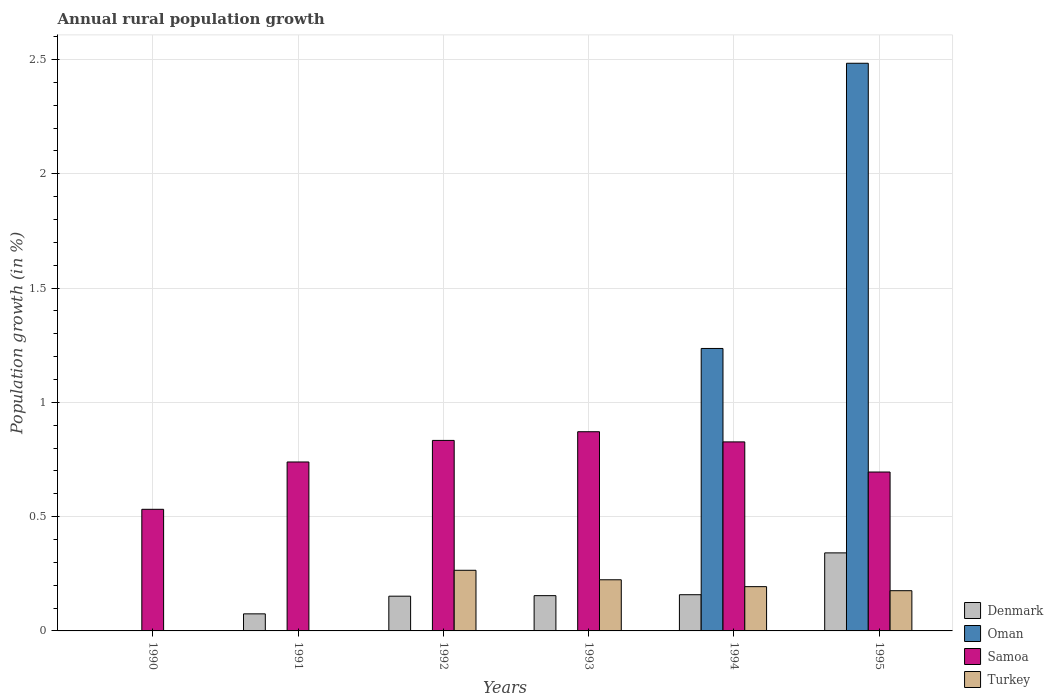How many different coloured bars are there?
Make the answer very short. 4. What is the percentage of rural population growth in Oman in 1992?
Offer a very short reply. 0. Across all years, what is the maximum percentage of rural population growth in Samoa?
Make the answer very short. 0.87. What is the total percentage of rural population growth in Oman in the graph?
Make the answer very short. 3.72. What is the difference between the percentage of rural population growth in Denmark in 1994 and that in 1995?
Give a very brief answer. -0.18. What is the difference between the percentage of rural population growth in Samoa in 1994 and the percentage of rural population growth in Oman in 1995?
Offer a very short reply. -1.66. What is the average percentage of rural population growth in Turkey per year?
Provide a short and direct response. 0.14. In the year 1995, what is the difference between the percentage of rural population growth in Denmark and percentage of rural population growth in Oman?
Your response must be concise. -2.14. What is the ratio of the percentage of rural population growth in Denmark in 1992 to that in 1993?
Your answer should be very brief. 0.98. Is the percentage of rural population growth in Samoa in 1993 less than that in 1995?
Your answer should be very brief. No. What is the difference between the highest and the second highest percentage of rural population growth in Denmark?
Your response must be concise. 0.18. What is the difference between the highest and the lowest percentage of rural population growth in Denmark?
Give a very brief answer. 0.34. Is the sum of the percentage of rural population growth in Turkey in 1992 and 1994 greater than the maximum percentage of rural population growth in Denmark across all years?
Provide a succinct answer. Yes. Is it the case that in every year, the sum of the percentage of rural population growth in Turkey and percentage of rural population growth in Oman is greater than the sum of percentage of rural population growth in Samoa and percentage of rural population growth in Denmark?
Your answer should be compact. No. Are all the bars in the graph horizontal?
Keep it short and to the point. No. Are the values on the major ticks of Y-axis written in scientific E-notation?
Offer a terse response. No. Does the graph contain any zero values?
Offer a terse response. Yes. Where does the legend appear in the graph?
Provide a succinct answer. Bottom right. How many legend labels are there?
Keep it short and to the point. 4. What is the title of the graph?
Ensure brevity in your answer.  Annual rural population growth. Does "Kenya" appear as one of the legend labels in the graph?
Offer a terse response. No. What is the label or title of the Y-axis?
Provide a short and direct response. Population growth (in %). What is the Population growth (in %) of Denmark in 1990?
Make the answer very short. 0. What is the Population growth (in %) of Samoa in 1990?
Make the answer very short. 0.53. What is the Population growth (in %) in Denmark in 1991?
Provide a short and direct response. 0.07. What is the Population growth (in %) of Samoa in 1991?
Offer a very short reply. 0.74. What is the Population growth (in %) of Denmark in 1992?
Provide a short and direct response. 0.15. What is the Population growth (in %) in Samoa in 1992?
Your answer should be very brief. 0.83. What is the Population growth (in %) of Turkey in 1992?
Provide a succinct answer. 0.27. What is the Population growth (in %) in Denmark in 1993?
Offer a terse response. 0.15. What is the Population growth (in %) of Oman in 1993?
Your response must be concise. 0. What is the Population growth (in %) in Samoa in 1993?
Your answer should be very brief. 0.87. What is the Population growth (in %) of Turkey in 1993?
Your answer should be compact. 0.22. What is the Population growth (in %) in Denmark in 1994?
Ensure brevity in your answer.  0.16. What is the Population growth (in %) in Oman in 1994?
Offer a terse response. 1.24. What is the Population growth (in %) of Samoa in 1994?
Provide a short and direct response. 0.83. What is the Population growth (in %) of Turkey in 1994?
Your response must be concise. 0.19. What is the Population growth (in %) of Denmark in 1995?
Provide a short and direct response. 0.34. What is the Population growth (in %) in Oman in 1995?
Your response must be concise. 2.48. What is the Population growth (in %) in Samoa in 1995?
Keep it short and to the point. 0.7. What is the Population growth (in %) in Turkey in 1995?
Keep it short and to the point. 0.18. Across all years, what is the maximum Population growth (in %) of Denmark?
Provide a succinct answer. 0.34. Across all years, what is the maximum Population growth (in %) of Oman?
Make the answer very short. 2.48. Across all years, what is the maximum Population growth (in %) in Samoa?
Your answer should be very brief. 0.87. Across all years, what is the maximum Population growth (in %) of Turkey?
Your response must be concise. 0.27. Across all years, what is the minimum Population growth (in %) in Denmark?
Make the answer very short. 0. Across all years, what is the minimum Population growth (in %) of Samoa?
Make the answer very short. 0.53. Across all years, what is the minimum Population growth (in %) in Turkey?
Provide a succinct answer. 0. What is the total Population growth (in %) in Denmark in the graph?
Make the answer very short. 0.88. What is the total Population growth (in %) in Oman in the graph?
Offer a terse response. 3.72. What is the total Population growth (in %) of Samoa in the graph?
Give a very brief answer. 4.5. What is the total Population growth (in %) of Turkey in the graph?
Give a very brief answer. 0.86. What is the difference between the Population growth (in %) in Samoa in 1990 and that in 1991?
Provide a short and direct response. -0.21. What is the difference between the Population growth (in %) of Samoa in 1990 and that in 1992?
Give a very brief answer. -0.3. What is the difference between the Population growth (in %) of Samoa in 1990 and that in 1993?
Provide a short and direct response. -0.34. What is the difference between the Population growth (in %) of Samoa in 1990 and that in 1994?
Give a very brief answer. -0.29. What is the difference between the Population growth (in %) of Samoa in 1990 and that in 1995?
Give a very brief answer. -0.16. What is the difference between the Population growth (in %) in Denmark in 1991 and that in 1992?
Provide a short and direct response. -0.08. What is the difference between the Population growth (in %) in Samoa in 1991 and that in 1992?
Provide a succinct answer. -0.09. What is the difference between the Population growth (in %) of Denmark in 1991 and that in 1993?
Your answer should be very brief. -0.08. What is the difference between the Population growth (in %) of Samoa in 1991 and that in 1993?
Your response must be concise. -0.13. What is the difference between the Population growth (in %) of Denmark in 1991 and that in 1994?
Give a very brief answer. -0.08. What is the difference between the Population growth (in %) in Samoa in 1991 and that in 1994?
Ensure brevity in your answer.  -0.09. What is the difference between the Population growth (in %) in Denmark in 1991 and that in 1995?
Your response must be concise. -0.27. What is the difference between the Population growth (in %) of Samoa in 1991 and that in 1995?
Your answer should be very brief. 0.04. What is the difference between the Population growth (in %) in Denmark in 1992 and that in 1993?
Your answer should be very brief. -0. What is the difference between the Population growth (in %) in Samoa in 1992 and that in 1993?
Keep it short and to the point. -0.04. What is the difference between the Population growth (in %) of Turkey in 1992 and that in 1993?
Provide a succinct answer. 0.04. What is the difference between the Population growth (in %) of Denmark in 1992 and that in 1994?
Provide a succinct answer. -0.01. What is the difference between the Population growth (in %) in Samoa in 1992 and that in 1994?
Offer a very short reply. 0.01. What is the difference between the Population growth (in %) of Turkey in 1992 and that in 1994?
Your response must be concise. 0.07. What is the difference between the Population growth (in %) in Denmark in 1992 and that in 1995?
Your answer should be compact. -0.19. What is the difference between the Population growth (in %) in Samoa in 1992 and that in 1995?
Offer a terse response. 0.14. What is the difference between the Population growth (in %) in Turkey in 1992 and that in 1995?
Keep it short and to the point. 0.09. What is the difference between the Population growth (in %) in Denmark in 1993 and that in 1994?
Provide a succinct answer. -0. What is the difference between the Population growth (in %) of Samoa in 1993 and that in 1994?
Your answer should be very brief. 0.04. What is the difference between the Population growth (in %) of Turkey in 1993 and that in 1994?
Provide a short and direct response. 0.03. What is the difference between the Population growth (in %) in Denmark in 1993 and that in 1995?
Provide a succinct answer. -0.19. What is the difference between the Population growth (in %) in Samoa in 1993 and that in 1995?
Provide a succinct answer. 0.18. What is the difference between the Population growth (in %) of Turkey in 1993 and that in 1995?
Give a very brief answer. 0.05. What is the difference between the Population growth (in %) in Denmark in 1994 and that in 1995?
Offer a terse response. -0.18. What is the difference between the Population growth (in %) in Oman in 1994 and that in 1995?
Make the answer very short. -1.25. What is the difference between the Population growth (in %) of Samoa in 1994 and that in 1995?
Keep it short and to the point. 0.13. What is the difference between the Population growth (in %) of Turkey in 1994 and that in 1995?
Offer a very short reply. 0.02. What is the difference between the Population growth (in %) of Samoa in 1990 and the Population growth (in %) of Turkey in 1992?
Offer a very short reply. 0.27. What is the difference between the Population growth (in %) of Samoa in 1990 and the Population growth (in %) of Turkey in 1993?
Offer a terse response. 0.31. What is the difference between the Population growth (in %) in Samoa in 1990 and the Population growth (in %) in Turkey in 1994?
Keep it short and to the point. 0.34. What is the difference between the Population growth (in %) in Samoa in 1990 and the Population growth (in %) in Turkey in 1995?
Provide a short and direct response. 0.36. What is the difference between the Population growth (in %) of Denmark in 1991 and the Population growth (in %) of Samoa in 1992?
Offer a terse response. -0.76. What is the difference between the Population growth (in %) in Denmark in 1991 and the Population growth (in %) in Turkey in 1992?
Your response must be concise. -0.19. What is the difference between the Population growth (in %) in Samoa in 1991 and the Population growth (in %) in Turkey in 1992?
Offer a very short reply. 0.47. What is the difference between the Population growth (in %) in Denmark in 1991 and the Population growth (in %) in Samoa in 1993?
Make the answer very short. -0.8. What is the difference between the Population growth (in %) in Denmark in 1991 and the Population growth (in %) in Turkey in 1993?
Your answer should be very brief. -0.15. What is the difference between the Population growth (in %) in Samoa in 1991 and the Population growth (in %) in Turkey in 1993?
Provide a short and direct response. 0.52. What is the difference between the Population growth (in %) of Denmark in 1991 and the Population growth (in %) of Oman in 1994?
Your response must be concise. -1.16. What is the difference between the Population growth (in %) in Denmark in 1991 and the Population growth (in %) in Samoa in 1994?
Ensure brevity in your answer.  -0.75. What is the difference between the Population growth (in %) in Denmark in 1991 and the Population growth (in %) in Turkey in 1994?
Your response must be concise. -0.12. What is the difference between the Population growth (in %) in Samoa in 1991 and the Population growth (in %) in Turkey in 1994?
Provide a succinct answer. 0.55. What is the difference between the Population growth (in %) in Denmark in 1991 and the Population growth (in %) in Oman in 1995?
Offer a terse response. -2.41. What is the difference between the Population growth (in %) in Denmark in 1991 and the Population growth (in %) in Samoa in 1995?
Ensure brevity in your answer.  -0.62. What is the difference between the Population growth (in %) of Denmark in 1991 and the Population growth (in %) of Turkey in 1995?
Make the answer very short. -0.1. What is the difference between the Population growth (in %) in Samoa in 1991 and the Population growth (in %) in Turkey in 1995?
Your answer should be very brief. 0.56. What is the difference between the Population growth (in %) in Denmark in 1992 and the Population growth (in %) in Samoa in 1993?
Provide a succinct answer. -0.72. What is the difference between the Population growth (in %) in Denmark in 1992 and the Population growth (in %) in Turkey in 1993?
Keep it short and to the point. -0.07. What is the difference between the Population growth (in %) of Samoa in 1992 and the Population growth (in %) of Turkey in 1993?
Provide a short and direct response. 0.61. What is the difference between the Population growth (in %) of Denmark in 1992 and the Population growth (in %) of Oman in 1994?
Your answer should be very brief. -1.08. What is the difference between the Population growth (in %) in Denmark in 1992 and the Population growth (in %) in Samoa in 1994?
Offer a terse response. -0.67. What is the difference between the Population growth (in %) of Denmark in 1992 and the Population growth (in %) of Turkey in 1994?
Your response must be concise. -0.04. What is the difference between the Population growth (in %) in Samoa in 1992 and the Population growth (in %) in Turkey in 1994?
Your answer should be very brief. 0.64. What is the difference between the Population growth (in %) of Denmark in 1992 and the Population growth (in %) of Oman in 1995?
Keep it short and to the point. -2.33. What is the difference between the Population growth (in %) of Denmark in 1992 and the Population growth (in %) of Samoa in 1995?
Your answer should be very brief. -0.54. What is the difference between the Population growth (in %) of Denmark in 1992 and the Population growth (in %) of Turkey in 1995?
Keep it short and to the point. -0.02. What is the difference between the Population growth (in %) of Samoa in 1992 and the Population growth (in %) of Turkey in 1995?
Keep it short and to the point. 0.66. What is the difference between the Population growth (in %) of Denmark in 1993 and the Population growth (in %) of Oman in 1994?
Give a very brief answer. -1.08. What is the difference between the Population growth (in %) in Denmark in 1993 and the Population growth (in %) in Samoa in 1994?
Provide a short and direct response. -0.67. What is the difference between the Population growth (in %) in Denmark in 1993 and the Population growth (in %) in Turkey in 1994?
Provide a short and direct response. -0.04. What is the difference between the Population growth (in %) in Samoa in 1993 and the Population growth (in %) in Turkey in 1994?
Provide a short and direct response. 0.68. What is the difference between the Population growth (in %) in Denmark in 1993 and the Population growth (in %) in Oman in 1995?
Your answer should be very brief. -2.33. What is the difference between the Population growth (in %) in Denmark in 1993 and the Population growth (in %) in Samoa in 1995?
Offer a very short reply. -0.54. What is the difference between the Population growth (in %) in Denmark in 1993 and the Population growth (in %) in Turkey in 1995?
Your answer should be compact. -0.02. What is the difference between the Population growth (in %) of Samoa in 1993 and the Population growth (in %) of Turkey in 1995?
Your answer should be very brief. 0.7. What is the difference between the Population growth (in %) of Denmark in 1994 and the Population growth (in %) of Oman in 1995?
Ensure brevity in your answer.  -2.32. What is the difference between the Population growth (in %) in Denmark in 1994 and the Population growth (in %) in Samoa in 1995?
Your response must be concise. -0.54. What is the difference between the Population growth (in %) in Denmark in 1994 and the Population growth (in %) in Turkey in 1995?
Your response must be concise. -0.02. What is the difference between the Population growth (in %) of Oman in 1994 and the Population growth (in %) of Samoa in 1995?
Offer a terse response. 0.54. What is the difference between the Population growth (in %) in Oman in 1994 and the Population growth (in %) in Turkey in 1995?
Make the answer very short. 1.06. What is the difference between the Population growth (in %) in Samoa in 1994 and the Population growth (in %) in Turkey in 1995?
Your answer should be compact. 0.65. What is the average Population growth (in %) of Denmark per year?
Keep it short and to the point. 0.15. What is the average Population growth (in %) in Oman per year?
Keep it short and to the point. 0.62. What is the average Population growth (in %) in Samoa per year?
Give a very brief answer. 0.75. What is the average Population growth (in %) of Turkey per year?
Make the answer very short. 0.14. In the year 1991, what is the difference between the Population growth (in %) of Denmark and Population growth (in %) of Samoa?
Offer a terse response. -0.66. In the year 1992, what is the difference between the Population growth (in %) in Denmark and Population growth (in %) in Samoa?
Ensure brevity in your answer.  -0.68. In the year 1992, what is the difference between the Population growth (in %) in Denmark and Population growth (in %) in Turkey?
Give a very brief answer. -0.11. In the year 1992, what is the difference between the Population growth (in %) of Samoa and Population growth (in %) of Turkey?
Your answer should be very brief. 0.57. In the year 1993, what is the difference between the Population growth (in %) in Denmark and Population growth (in %) in Samoa?
Your answer should be very brief. -0.72. In the year 1993, what is the difference between the Population growth (in %) of Denmark and Population growth (in %) of Turkey?
Offer a terse response. -0.07. In the year 1993, what is the difference between the Population growth (in %) of Samoa and Population growth (in %) of Turkey?
Your answer should be compact. 0.65. In the year 1994, what is the difference between the Population growth (in %) of Denmark and Population growth (in %) of Oman?
Your answer should be very brief. -1.08. In the year 1994, what is the difference between the Population growth (in %) in Denmark and Population growth (in %) in Samoa?
Make the answer very short. -0.67. In the year 1994, what is the difference between the Population growth (in %) in Denmark and Population growth (in %) in Turkey?
Keep it short and to the point. -0.04. In the year 1994, what is the difference between the Population growth (in %) of Oman and Population growth (in %) of Samoa?
Ensure brevity in your answer.  0.41. In the year 1994, what is the difference between the Population growth (in %) in Oman and Population growth (in %) in Turkey?
Offer a very short reply. 1.04. In the year 1994, what is the difference between the Population growth (in %) in Samoa and Population growth (in %) in Turkey?
Make the answer very short. 0.63. In the year 1995, what is the difference between the Population growth (in %) in Denmark and Population growth (in %) in Oman?
Keep it short and to the point. -2.14. In the year 1995, what is the difference between the Population growth (in %) of Denmark and Population growth (in %) of Samoa?
Make the answer very short. -0.35. In the year 1995, what is the difference between the Population growth (in %) in Denmark and Population growth (in %) in Turkey?
Offer a terse response. 0.17. In the year 1995, what is the difference between the Population growth (in %) of Oman and Population growth (in %) of Samoa?
Give a very brief answer. 1.79. In the year 1995, what is the difference between the Population growth (in %) in Oman and Population growth (in %) in Turkey?
Provide a succinct answer. 2.31. In the year 1995, what is the difference between the Population growth (in %) of Samoa and Population growth (in %) of Turkey?
Keep it short and to the point. 0.52. What is the ratio of the Population growth (in %) of Samoa in 1990 to that in 1991?
Offer a very short reply. 0.72. What is the ratio of the Population growth (in %) of Samoa in 1990 to that in 1992?
Provide a short and direct response. 0.64. What is the ratio of the Population growth (in %) of Samoa in 1990 to that in 1993?
Make the answer very short. 0.61. What is the ratio of the Population growth (in %) of Samoa in 1990 to that in 1994?
Your answer should be very brief. 0.64. What is the ratio of the Population growth (in %) of Samoa in 1990 to that in 1995?
Make the answer very short. 0.77. What is the ratio of the Population growth (in %) of Denmark in 1991 to that in 1992?
Provide a short and direct response. 0.49. What is the ratio of the Population growth (in %) in Samoa in 1991 to that in 1992?
Make the answer very short. 0.89. What is the ratio of the Population growth (in %) of Denmark in 1991 to that in 1993?
Your answer should be very brief. 0.48. What is the ratio of the Population growth (in %) in Samoa in 1991 to that in 1993?
Provide a short and direct response. 0.85. What is the ratio of the Population growth (in %) of Denmark in 1991 to that in 1994?
Your answer should be very brief. 0.47. What is the ratio of the Population growth (in %) in Samoa in 1991 to that in 1994?
Keep it short and to the point. 0.89. What is the ratio of the Population growth (in %) of Denmark in 1991 to that in 1995?
Offer a terse response. 0.22. What is the ratio of the Population growth (in %) of Samoa in 1991 to that in 1995?
Your answer should be compact. 1.06. What is the ratio of the Population growth (in %) of Denmark in 1992 to that in 1993?
Give a very brief answer. 0.98. What is the ratio of the Population growth (in %) in Samoa in 1992 to that in 1993?
Your answer should be compact. 0.96. What is the ratio of the Population growth (in %) of Turkey in 1992 to that in 1993?
Make the answer very short. 1.19. What is the ratio of the Population growth (in %) in Denmark in 1992 to that in 1994?
Keep it short and to the point. 0.96. What is the ratio of the Population growth (in %) in Turkey in 1992 to that in 1994?
Your answer should be very brief. 1.37. What is the ratio of the Population growth (in %) of Denmark in 1992 to that in 1995?
Give a very brief answer. 0.45. What is the ratio of the Population growth (in %) in Samoa in 1992 to that in 1995?
Offer a very short reply. 1.2. What is the ratio of the Population growth (in %) in Turkey in 1992 to that in 1995?
Offer a very short reply. 1.51. What is the ratio of the Population growth (in %) of Denmark in 1993 to that in 1994?
Ensure brevity in your answer.  0.97. What is the ratio of the Population growth (in %) of Samoa in 1993 to that in 1994?
Ensure brevity in your answer.  1.05. What is the ratio of the Population growth (in %) of Turkey in 1993 to that in 1994?
Offer a terse response. 1.16. What is the ratio of the Population growth (in %) of Denmark in 1993 to that in 1995?
Ensure brevity in your answer.  0.45. What is the ratio of the Population growth (in %) of Samoa in 1993 to that in 1995?
Ensure brevity in your answer.  1.25. What is the ratio of the Population growth (in %) of Turkey in 1993 to that in 1995?
Provide a short and direct response. 1.27. What is the ratio of the Population growth (in %) of Denmark in 1994 to that in 1995?
Offer a terse response. 0.46. What is the ratio of the Population growth (in %) in Oman in 1994 to that in 1995?
Ensure brevity in your answer.  0.5. What is the ratio of the Population growth (in %) of Samoa in 1994 to that in 1995?
Your answer should be very brief. 1.19. What is the ratio of the Population growth (in %) of Turkey in 1994 to that in 1995?
Keep it short and to the point. 1.1. What is the difference between the highest and the second highest Population growth (in %) of Denmark?
Provide a short and direct response. 0.18. What is the difference between the highest and the second highest Population growth (in %) of Samoa?
Provide a succinct answer. 0.04. What is the difference between the highest and the second highest Population growth (in %) of Turkey?
Your answer should be very brief. 0.04. What is the difference between the highest and the lowest Population growth (in %) in Denmark?
Your response must be concise. 0.34. What is the difference between the highest and the lowest Population growth (in %) in Oman?
Make the answer very short. 2.48. What is the difference between the highest and the lowest Population growth (in %) of Samoa?
Your answer should be very brief. 0.34. What is the difference between the highest and the lowest Population growth (in %) of Turkey?
Offer a terse response. 0.27. 